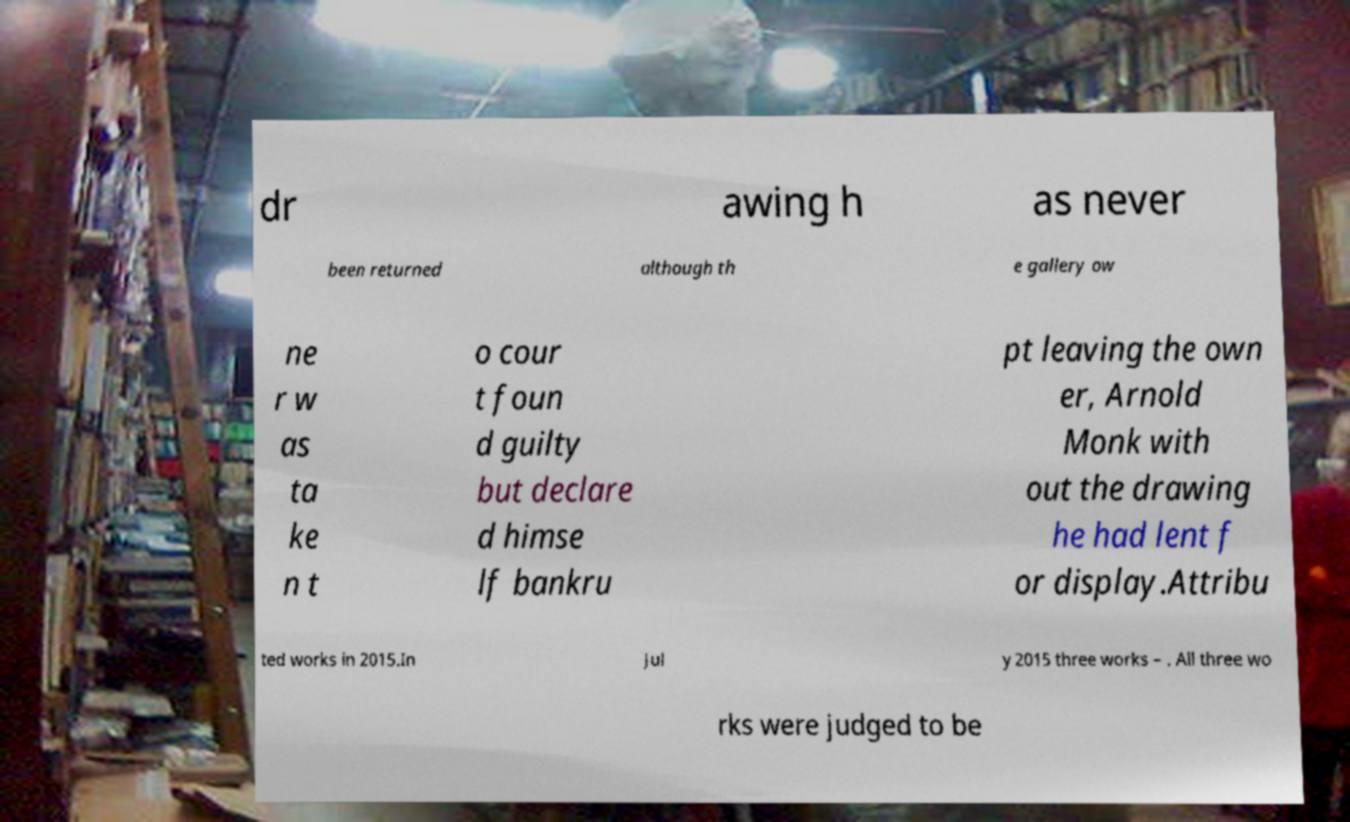Could you extract and type out the text from this image? dr awing h as never been returned although th e gallery ow ne r w as ta ke n t o cour t foun d guilty but declare d himse lf bankru pt leaving the own er, Arnold Monk with out the drawing he had lent f or display.Attribu ted works in 2015.In Jul y 2015 three works – . All three wo rks were judged to be 